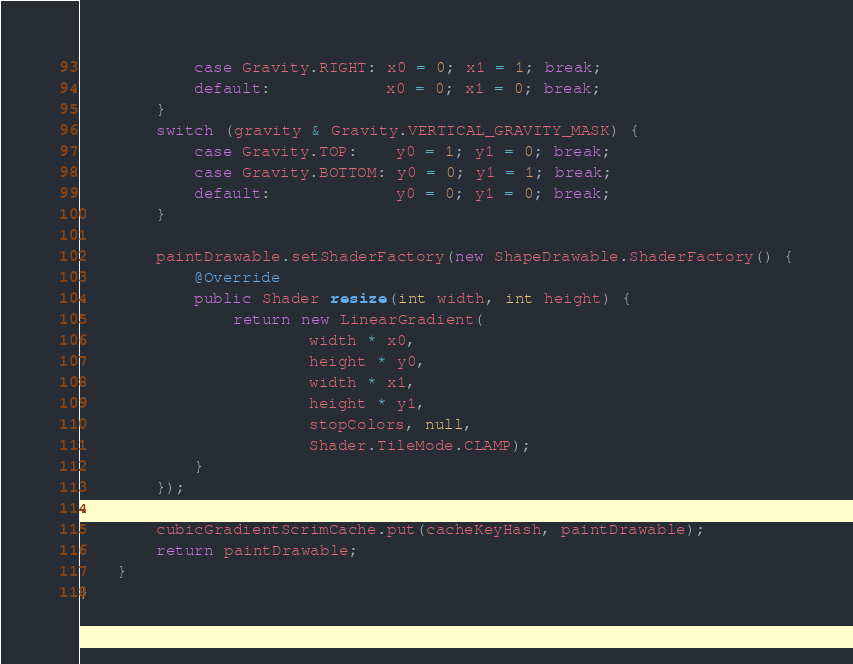<code> <loc_0><loc_0><loc_500><loc_500><_Java_>            case Gravity.RIGHT: x0 = 0; x1 = 1; break;
            default:            x0 = 0; x1 = 0; break;
        }
        switch (gravity & Gravity.VERTICAL_GRAVITY_MASK) {
            case Gravity.TOP:    y0 = 1; y1 = 0; break;
            case Gravity.BOTTOM: y0 = 0; y1 = 1; break;
            default:             y0 = 0; y1 = 0; break;
        }

        paintDrawable.setShaderFactory(new ShapeDrawable.ShaderFactory() {
            @Override
            public Shader resize(int width, int height) {
                return new LinearGradient(
                        width * x0,
                        height * y0,
                        width * x1,
                        height * y1,
                        stopColors, null,
                        Shader.TileMode.CLAMP);
            }
        });

        cubicGradientScrimCache.put(cacheKeyHash, paintDrawable);
        return paintDrawable;
    }
}</code> 